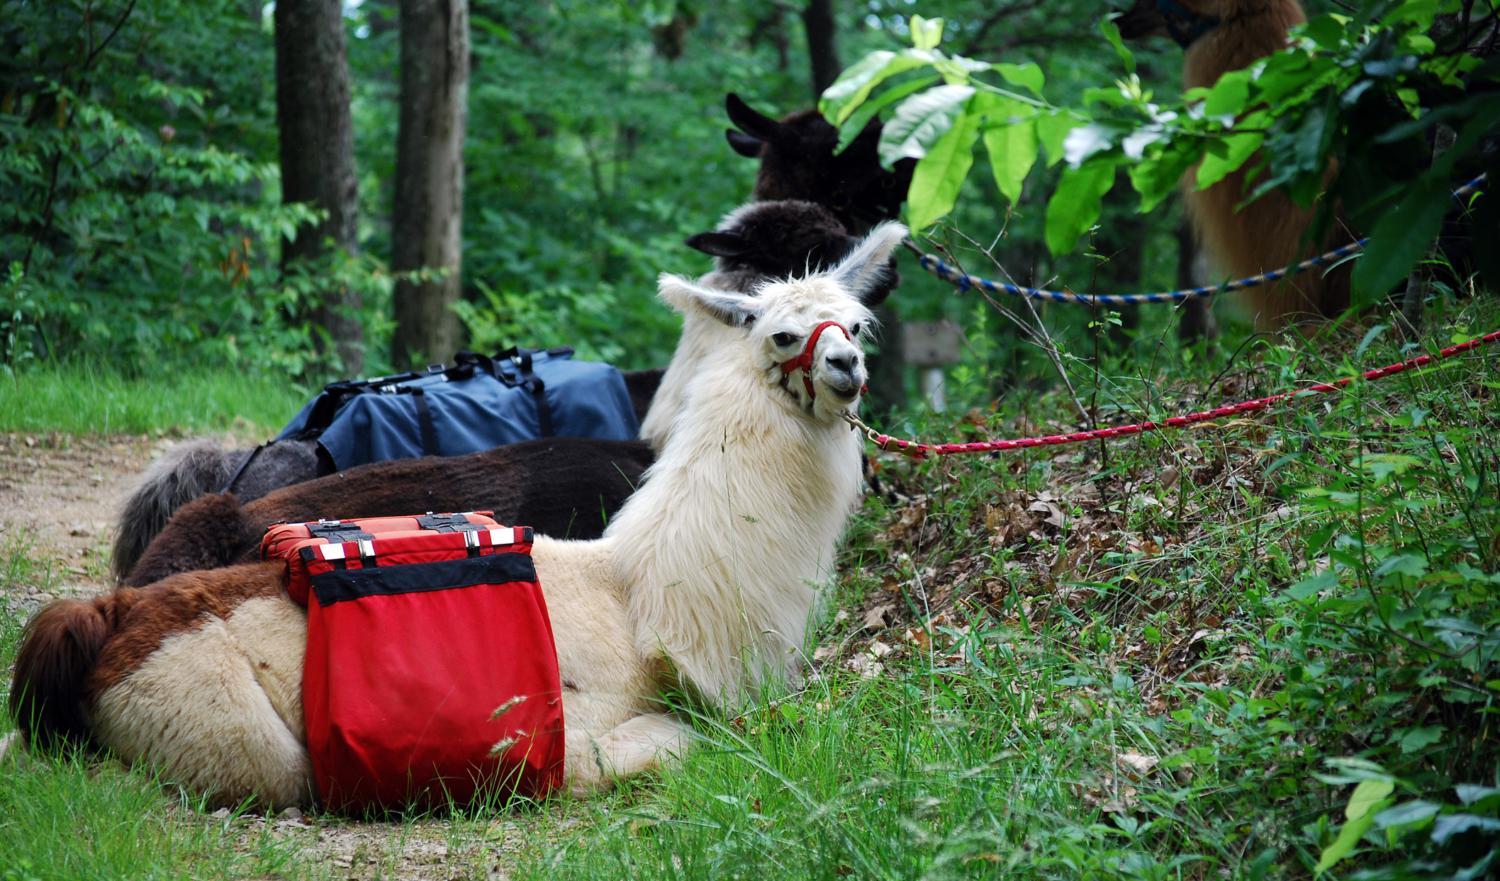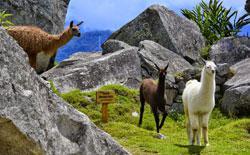The first image is the image on the left, the second image is the image on the right. Assess this claim about the two images: "There are three llamas standing in the left image.". Correct or not? Answer yes or no. No. 